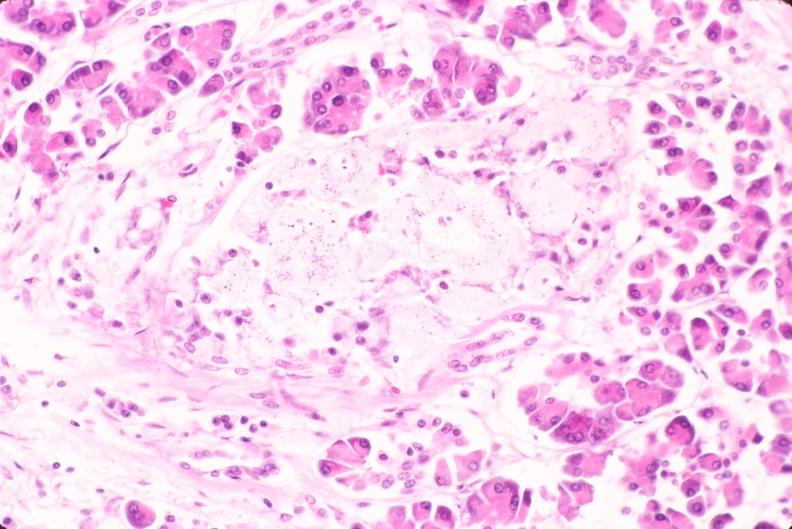what does this image show?
Answer the question using a single word or phrase. Pancreas 